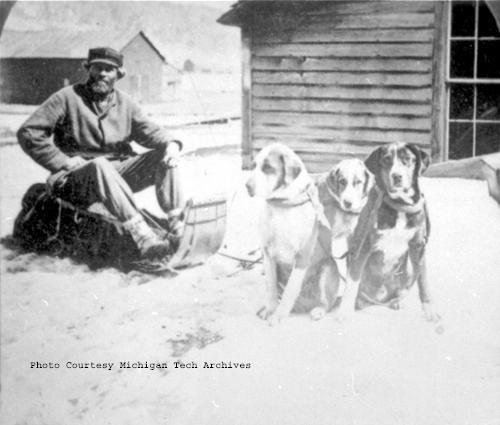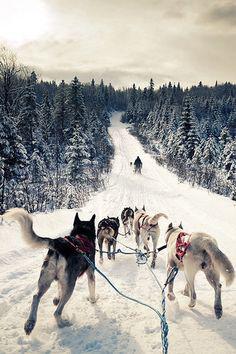The first image is the image on the left, the second image is the image on the right. Examine the images to the left and right. Is the description "A person bundled in fur for warm is posing behind one sled dog in the right image." accurate? Answer yes or no. No. The first image is the image on the left, the second image is the image on the right. Evaluate the accuracy of this statement regarding the images: "In at least one image there is  a single sled dog with it's owner posing behind them.". Is it true? Answer yes or no. No. 